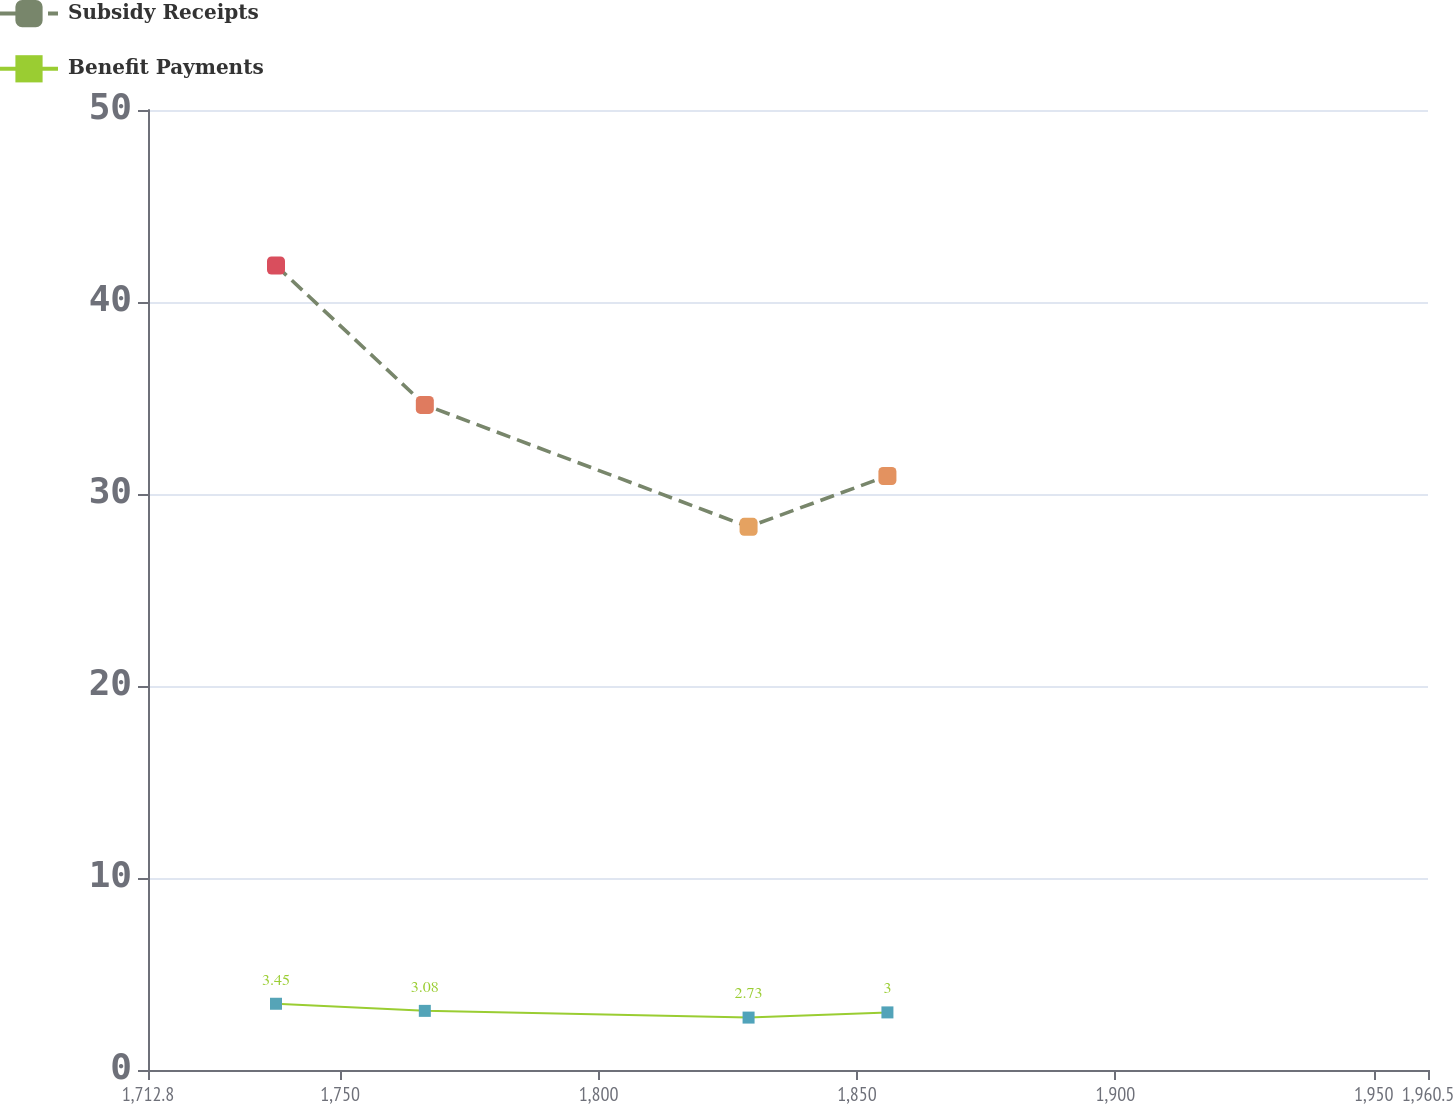Convert chart to OTSL. <chart><loc_0><loc_0><loc_500><loc_500><line_chart><ecel><fcel>Subsidy Receipts<fcel>Benefit Payments<nl><fcel>1737.57<fcel>41.9<fcel>3.45<nl><fcel>1766.37<fcel>34.64<fcel>3.08<nl><fcel>1829.02<fcel>28.29<fcel>2.73<nl><fcel>1855.89<fcel>30.94<fcel>3<nl><fcel>1985.27<fcel>25.81<fcel>3.53<nl></chart> 